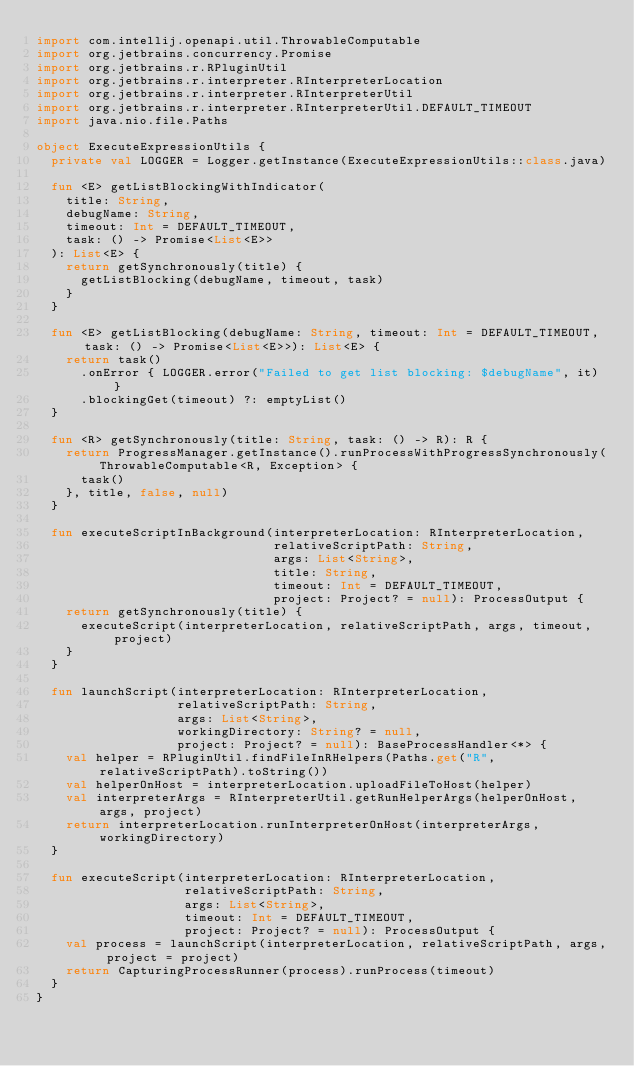<code> <loc_0><loc_0><loc_500><loc_500><_Kotlin_>import com.intellij.openapi.util.ThrowableComputable
import org.jetbrains.concurrency.Promise
import org.jetbrains.r.RPluginUtil
import org.jetbrains.r.interpreter.RInterpreterLocation
import org.jetbrains.r.interpreter.RInterpreterUtil
import org.jetbrains.r.interpreter.RInterpreterUtil.DEFAULT_TIMEOUT
import java.nio.file.Paths

object ExecuteExpressionUtils {
  private val LOGGER = Logger.getInstance(ExecuteExpressionUtils::class.java)

  fun <E> getListBlockingWithIndicator(
    title: String,
    debugName: String,
    timeout: Int = DEFAULT_TIMEOUT,
    task: () -> Promise<List<E>>
  ): List<E> {
    return getSynchronously(title) {
      getListBlocking(debugName, timeout, task)
    }
  }

  fun <E> getListBlocking(debugName: String, timeout: Int = DEFAULT_TIMEOUT, task: () -> Promise<List<E>>): List<E> {
    return task()
      .onError { LOGGER.error("Failed to get list blocking: $debugName", it) }
      .blockingGet(timeout) ?: emptyList()
  }

  fun <R> getSynchronously(title: String, task: () -> R): R {
    return ProgressManager.getInstance().runProcessWithProgressSynchronously(ThrowableComputable<R, Exception> {
      task()
    }, title, false, null)
  }

  fun executeScriptInBackground(interpreterLocation: RInterpreterLocation,
                                relativeScriptPath: String,
                                args: List<String>,
                                title: String,
                                timeout: Int = DEFAULT_TIMEOUT,
                                project: Project? = null): ProcessOutput {
    return getSynchronously(title) {
      executeScript(interpreterLocation, relativeScriptPath, args, timeout, project)
    }
  }

  fun launchScript(interpreterLocation: RInterpreterLocation,
                   relativeScriptPath: String,
                   args: List<String>,
                   workingDirectory: String? = null,
                   project: Project? = null): BaseProcessHandler<*> {
    val helper = RPluginUtil.findFileInRHelpers(Paths.get("R", relativeScriptPath).toString())
    val helperOnHost = interpreterLocation.uploadFileToHost(helper)
    val interpreterArgs = RInterpreterUtil.getRunHelperArgs(helperOnHost, args, project)
    return interpreterLocation.runInterpreterOnHost(interpreterArgs, workingDirectory)
  }

  fun executeScript(interpreterLocation: RInterpreterLocation,
                    relativeScriptPath: String,
                    args: List<String>,
                    timeout: Int = DEFAULT_TIMEOUT,
                    project: Project? = null): ProcessOutput {
    val process = launchScript(interpreterLocation, relativeScriptPath, args, project = project)
    return CapturingProcessRunner(process).runProcess(timeout)
  }
}</code> 